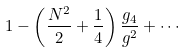<formula> <loc_0><loc_0><loc_500><loc_500>1 - \left ( \frac { N ^ { 2 } } { 2 } + \frac { 1 } { 4 } \right ) \frac { g _ { 4 } } { g ^ { 2 } } + \cdots</formula> 